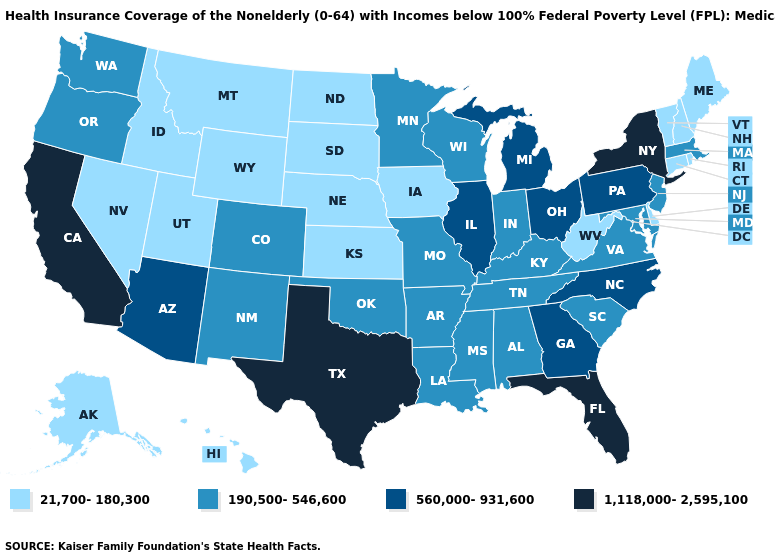Name the states that have a value in the range 1,118,000-2,595,100?
Keep it brief. California, Florida, New York, Texas. Among the states that border Indiana , which have the lowest value?
Concise answer only. Kentucky. Does Minnesota have the lowest value in the USA?
Give a very brief answer. No. Does North Carolina have the same value as Florida?
Concise answer only. No. What is the value of Pennsylvania?
Write a very short answer. 560,000-931,600. What is the lowest value in states that border Louisiana?
Keep it brief. 190,500-546,600. Name the states that have a value in the range 1,118,000-2,595,100?
Concise answer only. California, Florida, New York, Texas. Does the map have missing data?
Give a very brief answer. No. What is the value of North Dakota?
Be succinct. 21,700-180,300. Name the states that have a value in the range 190,500-546,600?
Write a very short answer. Alabama, Arkansas, Colorado, Indiana, Kentucky, Louisiana, Maryland, Massachusetts, Minnesota, Mississippi, Missouri, New Jersey, New Mexico, Oklahoma, Oregon, South Carolina, Tennessee, Virginia, Washington, Wisconsin. Among the states that border West Virginia , which have the highest value?
Write a very short answer. Ohio, Pennsylvania. Does New York have the highest value in the Northeast?
Answer briefly. Yes. Name the states that have a value in the range 560,000-931,600?
Keep it brief. Arizona, Georgia, Illinois, Michigan, North Carolina, Ohio, Pennsylvania. Among the states that border Nevada , does California have the highest value?
Quick response, please. Yes. Does Maine have a lower value than North Dakota?
Write a very short answer. No. 